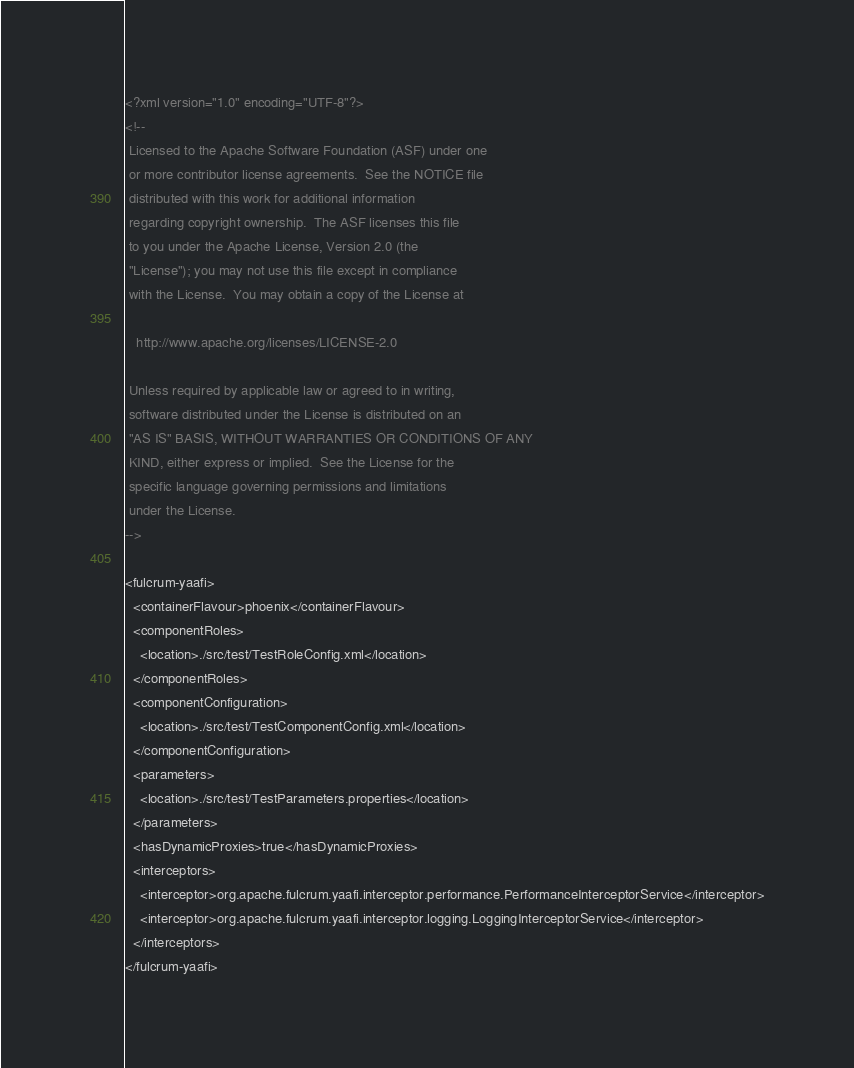<code> <loc_0><loc_0><loc_500><loc_500><_XML_><?xml version="1.0" encoding="UTF-8"?>
<!--
 Licensed to the Apache Software Foundation (ASF) under one
 or more contributor license agreements.  See the NOTICE file
 distributed with this work for additional information
 regarding copyright ownership.  The ASF licenses this file
 to you under the Apache License, Version 2.0 (the
 "License"); you may not use this file except in compliance
 with the License.  You may obtain a copy of the License at

   http://www.apache.org/licenses/LICENSE-2.0

 Unless required by applicable law or agreed to in writing,
 software distributed under the License is distributed on an
 "AS IS" BASIS, WITHOUT WARRANTIES OR CONDITIONS OF ANY
 KIND, either express or implied.  See the License for the
 specific language governing permissions and limitations
 under the License.
-->

<fulcrum-yaafi>
  <containerFlavour>phoenix</containerFlavour>
  <componentRoles>
    <location>./src/test/TestRoleConfig.xml</location>
  </componentRoles>
  <componentConfiguration>
    <location>./src/test/TestComponentConfig.xml</location>
  </componentConfiguration>
  <parameters>
    <location>./src/test/TestParameters.properties</location>
  </parameters>
  <hasDynamicProxies>true</hasDynamicProxies>
  <interceptors>
    <interceptor>org.apache.fulcrum.yaafi.interceptor.performance.PerformanceInterceptorService</interceptor>
    <interceptor>org.apache.fulcrum.yaafi.interceptor.logging.LoggingInterceptorService</interceptor>
  </interceptors>
</fulcrum-yaafi>
</code> 